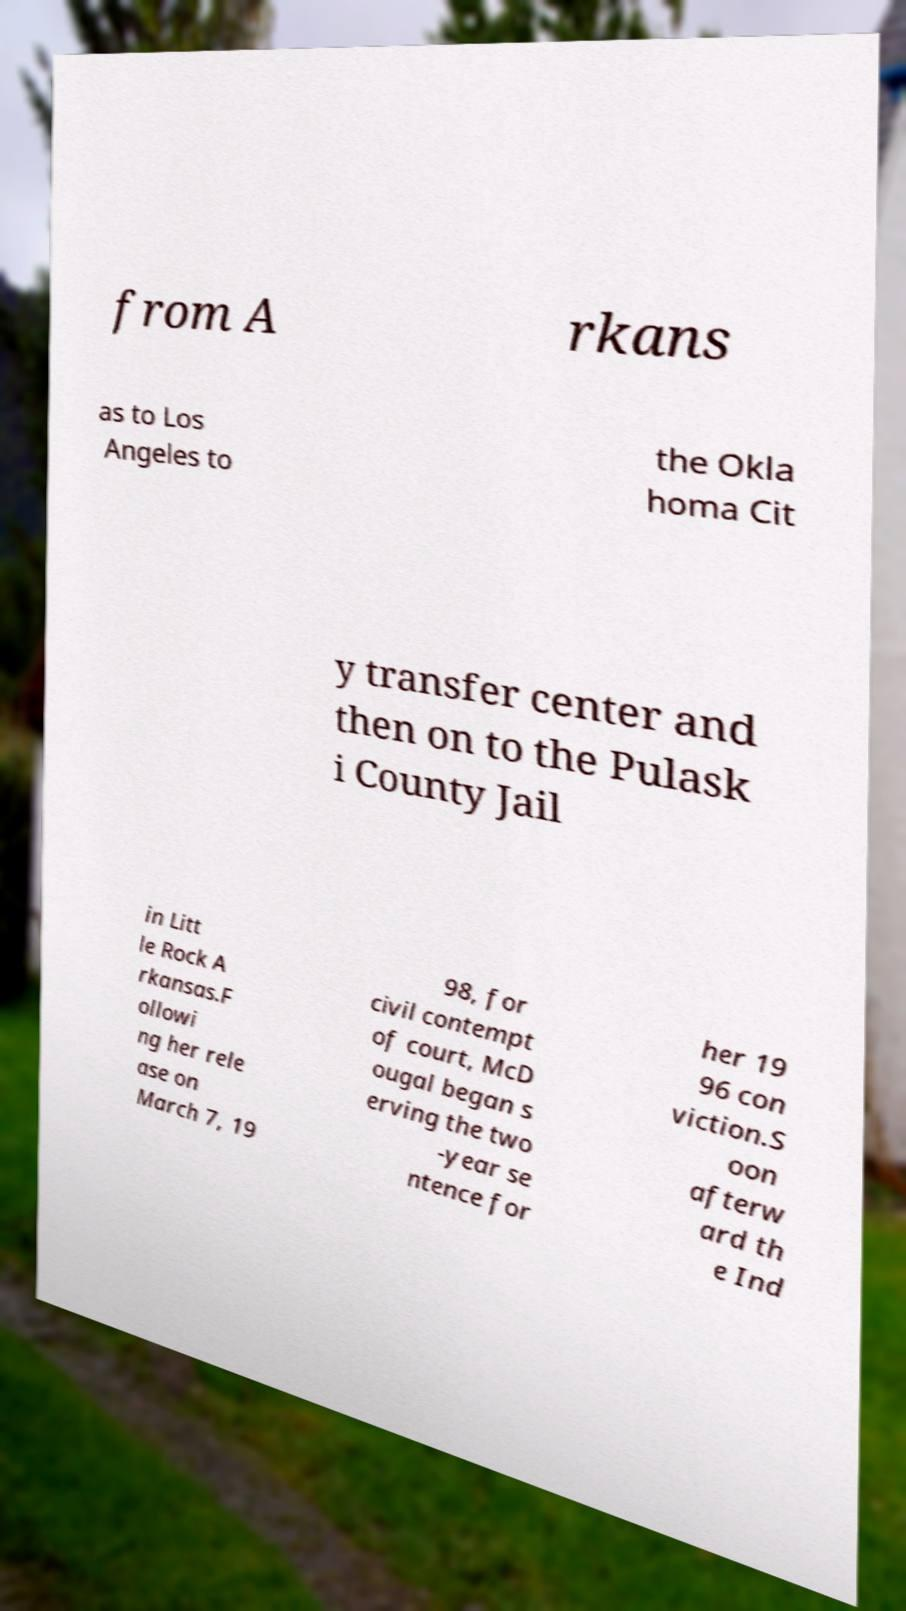Please identify and transcribe the text found in this image. from A rkans as to Los Angeles to the Okla homa Cit y transfer center and then on to the Pulask i County Jail in Litt le Rock A rkansas.F ollowi ng her rele ase on March 7, 19 98, for civil contempt of court, McD ougal began s erving the two -year se ntence for her 19 96 con viction.S oon afterw ard th e Ind 